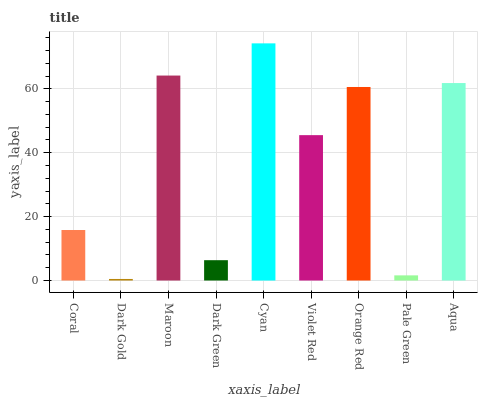Is Dark Gold the minimum?
Answer yes or no. Yes. Is Cyan the maximum?
Answer yes or no. Yes. Is Maroon the minimum?
Answer yes or no. No. Is Maroon the maximum?
Answer yes or no. No. Is Maroon greater than Dark Gold?
Answer yes or no. Yes. Is Dark Gold less than Maroon?
Answer yes or no. Yes. Is Dark Gold greater than Maroon?
Answer yes or no. No. Is Maroon less than Dark Gold?
Answer yes or no. No. Is Violet Red the high median?
Answer yes or no. Yes. Is Violet Red the low median?
Answer yes or no. Yes. Is Cyan the high median?
Answer yes or no. No. Is Dark Green the low median?
Answer yes or no. No. 